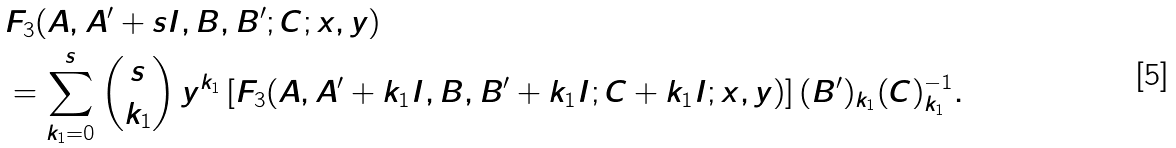<formula> <loc_0><loc_0><loc_500><loc_500>& F _ { 3 } ( A , A ^ { \prime } + s I , B , B ^ { \prime } ; C ; x , y ) \\ & = \sum _ { k _ { 1 } = 0 } ^ { s } { s \choose k _ { 1 } } \, y ^ { k _ { 1 } } \left [ { F _ { 3 } } ( A , A ^ { \prime } + k _ { 1 } I , B , B ^ { \prime } + k _ { 1 } I ; C + k _ { 1 } I ; x , y ) \right ] { ( B ^ { \prime } ) _ { k _ { 1 } } } { ( C ) ^ { - 1 } _ { k _ { 1 } } } .</formula> 